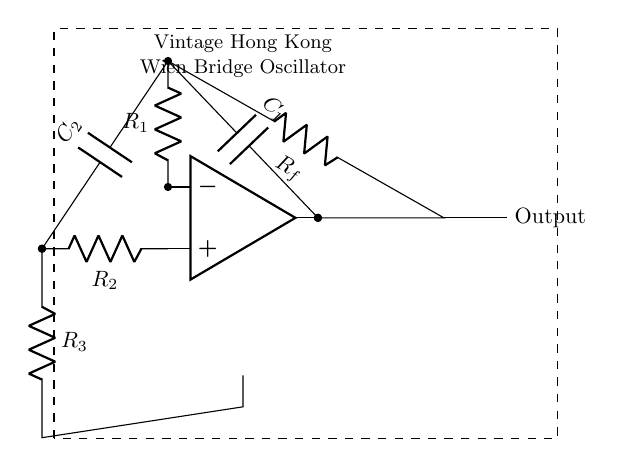What is the key component that defines this circuit as an oscillator? The operational amplifier is the key component in this circuit, as it is responsible for amplifying the signal to generate oscillation.
Answer: Operational amplifier What is the output of this circuit labeled as? The output is labeled 'Output' in the circuit, indicating where the oscillating signal can be retrieved.
Answer: Output What is the value of the capacitor connected to R2? The capacitor connected to R2 is labeled C2, which is one of the capacitors used in the Wien bridge configuration for feedback.
Answer: C2 What is the purpose of Rf in the circuit? Rf acts as a feedback resistor that helps establish the gain needed for oscillation in the Wien Bridge Oscillator.
Answer: Feedback resistor How many resistors are present in the circuit? There are three resistors (R1, R2, and R3) in the circuit, contributing to the circuit's functioning and oscillation stability.
Answer: Three What does the dashed rectangle around the circuit indicate? The dashed rectangle generally indicates a boundary of a functional unit or module, separating this oscillator circuit from other surrounding circuitry.
Answer: Boundary of the oscillator What type of audio product commonly used this circuit in Hong Kong? Vintage audio oscillators commonly used this type of Wien Bridge Oscillator circuit in their design during the industrial development in Hong Kong.
Answer: Vintage audio oscillators 